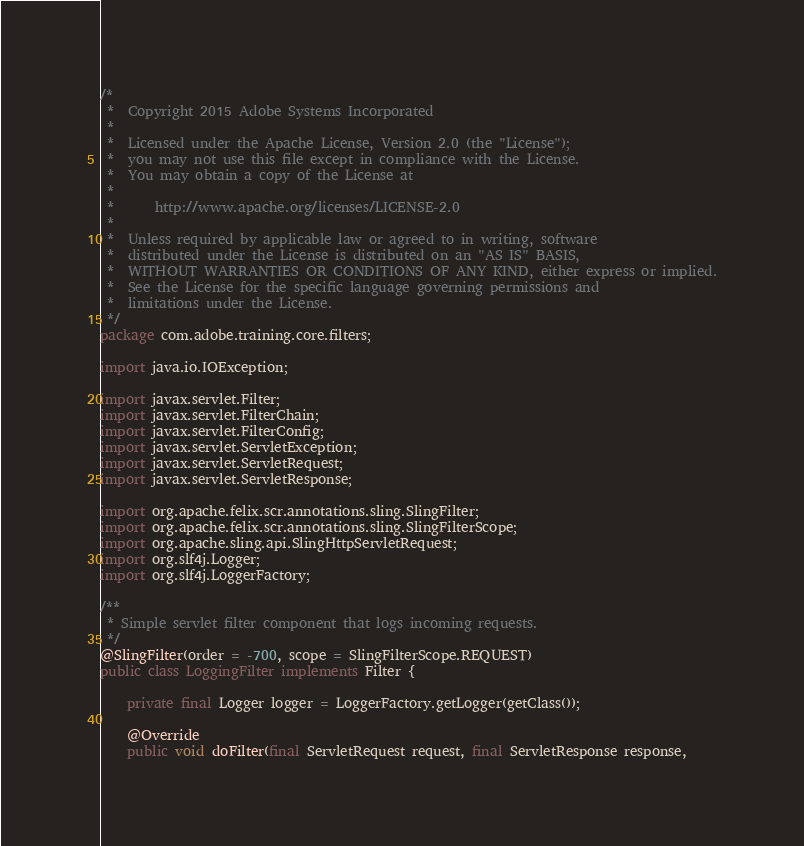Convert code to text. <code><loc_0><loc_0><loc_500><loc_500><_Java_>/*
 *  Copyright 2015 Adobe Systems Incorporated
 *
 *  Licensed under the Apache License, Version 2.0 (the "License");
 *  you may not use this file except in compliance with the License.
 *  You may obtain a copy of the License at
 *
 *      http://www.apache.org/licenses/LICENSE-2.0
 *
 *  Unless required by applicable law or agreed to in writing, software
 *  distributed under the License is distributed on an "AS IS" BASIS,
 *  WITHOUT WARRANTIES OR CONDITIONS OF ANY KIND, either express or implied.
 *  See the License for the specific language governing permissions and
 *  limitations under the License.
 */
package com.adobe.training.core.filters;

import java.io.IOException;

import javax.servlet.Filter;
import javax.servlet.FilterChain;
import javax.servlet.FilterConfig;
import javax.servlet.ServletException;
import javax.servlet.ServletRequest;
import javax.servlet.ServletResponse;

import org.apache.felix.scr.annotations.sling.SlingFilter;
import org.apache.felix.scr.annotations.sling.SlingFilterScope;
import org.apache.sling.api.SlingHttpServletRequest;
import org.slf4j.Logger;
import org.slf4j.LoggerFactory;

/**
 * Simple servlet filter component that logs incoming requests.
 */
@SlingFilter(order = -700, scope = SlingFilterScope.REQUEST)
public class LoggingFilter implements Filter {

    private final Logger logger = LoggerFactory.getLogger(getClass());

    @Override
    public void doFilter(final ServletRequest request, final ServletResponse response,</code> 